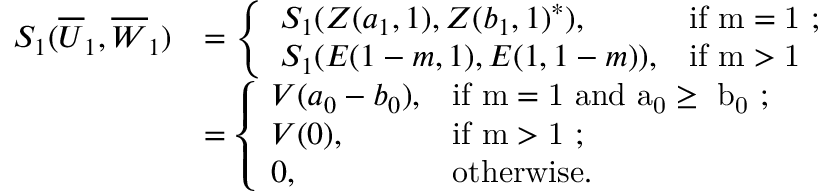<formula> <loc_0><loc_0><loc_500><loc_500>\begin{array} { r l } { S _ { 1 } ( \overline { U } _ { 1 } , \overline { W } _ { 1 } ) } & { = \left \{ \begin{array} { l l } { S _ { 1 } ( Z ( a _ { 1 } , 1 ) , Z ( b _ { 1 } , 1 ) ^ { * } ) , } & { i f m = 1 ; } \\ { S _ { 1 } ( E ( 1 - m , 1 ) , E ( 1 , 1 - m ) ) , } & { i f m > 1 } \end{array} } \\ & { = \left \{ \begin{array} { l l } { V ( a _ { 0 } - b _ { 0 } ) , } & { i f m = 1 a n d a _ { 0 } \geq b _ { 0 } ; } \\ { V ( 0 ) , } & { i f m > 1 ; } \\ { 0 , } & { o t h e r w i s e . } \end{array} } \end{array}</formula> 